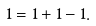<formula> <loc_0><loc_0><loc_500><loc_500>1 = 1 + 1 - 1 .</formula> 